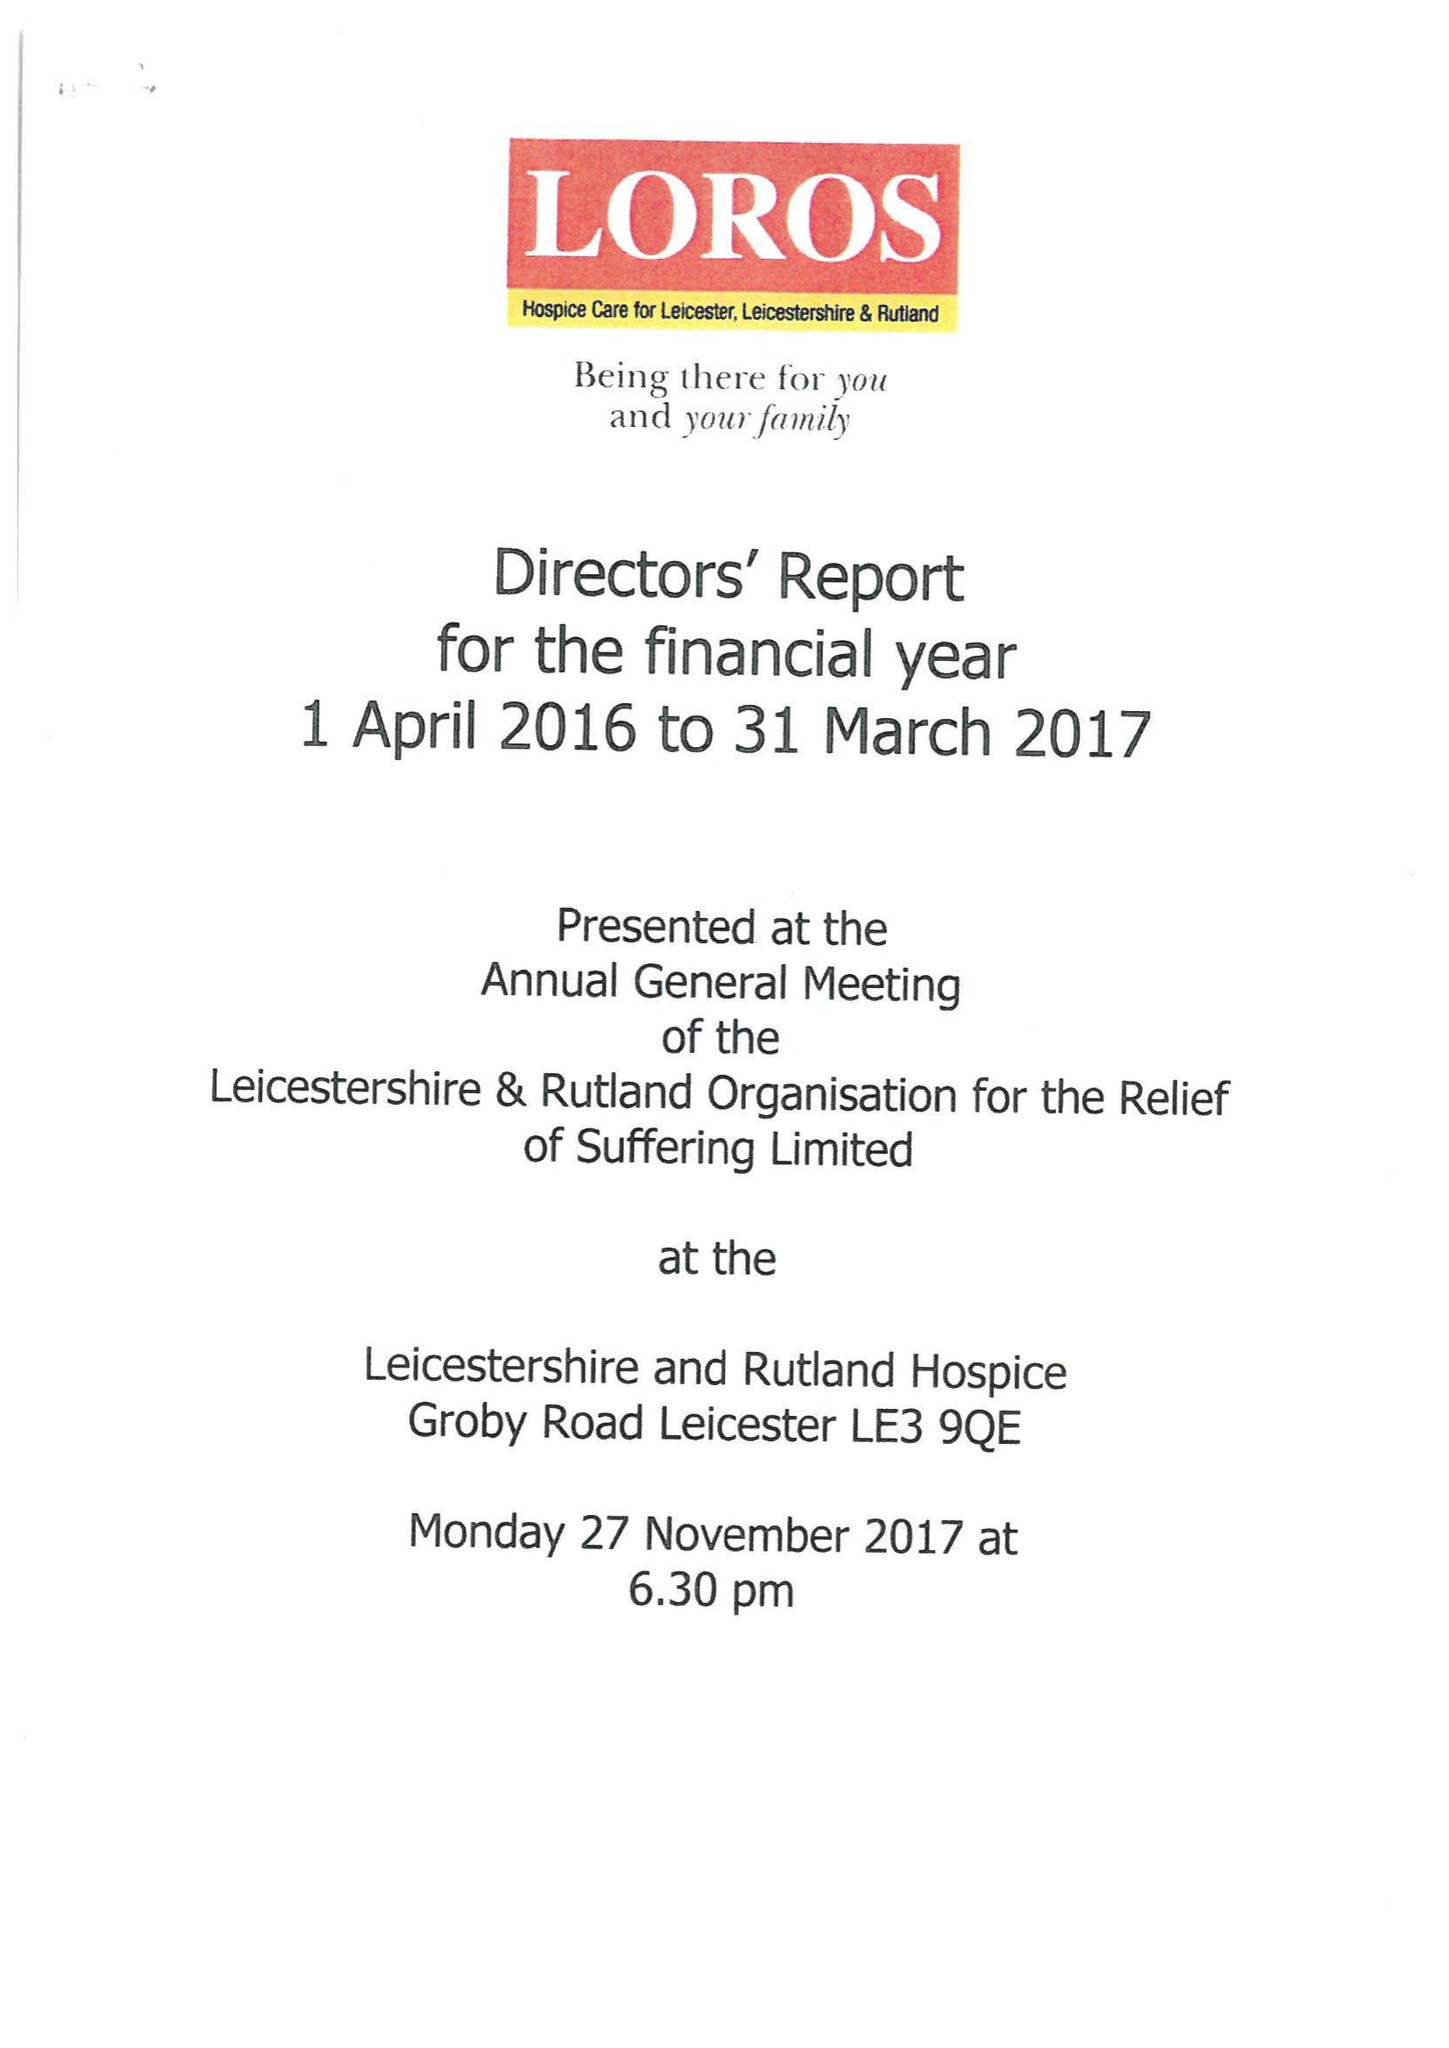What is the value for the address__street_line?
Answer the question using a single word or phrase. GROBY ROAD 